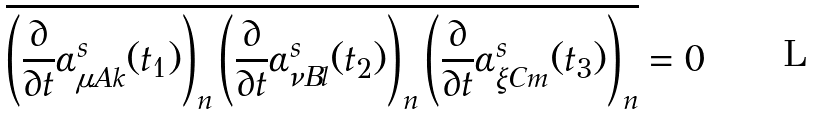Convert formula to latex. <formula><loc_0><loc_0><loc_500><loc_500>\overline { \left ( \frac { \partial } { \partial t } \alpha _ { \mu A k } ^ { s } ( t _ { 1 } ) \right ) _ { n } \left ( \frac { \partial } { \partial t } \alpha _ { \nu B l } ^ { s } ( t _ { 2 } ) \right ) _ { n } \left ( \frac { \partial } { \partial t } \alpha _ { \xi C m } ^ { s } ( t _ { 3 } ) \right ) _ { n } } = 0</formula> 